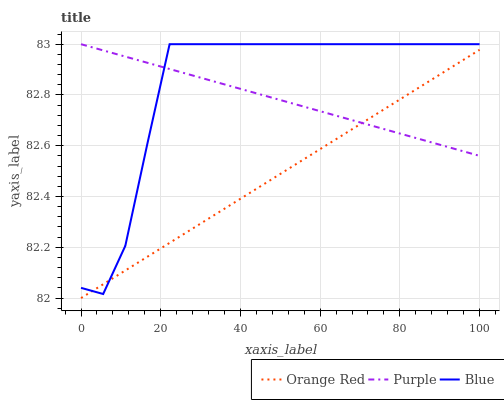Does Blue have the minimum area under the curve?
Answer yes or no. No. Does Orange Red have the maximum area under the curve?
Answer yes or no. No. Is Orange Red the smoothest?
Answer yes or no. No. Is Orange Red the roughest?
Answer yes or no. No. Does Blue have the lowest value?
Answer yes or no. No. Does Orange Red have the highest value?
Answer yes or no. No. 